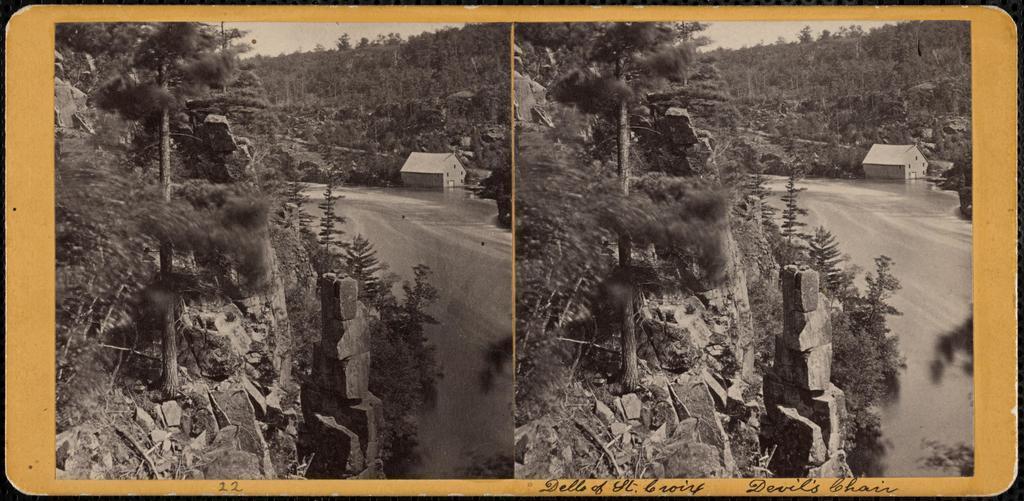Describe this image in one or two sentences. In this image we can see a collage of black and white pictures. In which we can see a building with windows, a group of trees and some rocks. At the top of the image we can see the sky. 